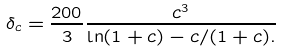Convert formula to latex. <formula><loc_0><loc_0><loc_500><loc_500>\delta _ { c } = \frac { 2 0 0 } { 3 } \frac { c ^ { 3 } } { \ln ( 1 + c ) - c / ( 1 + c ) . }</formula> 